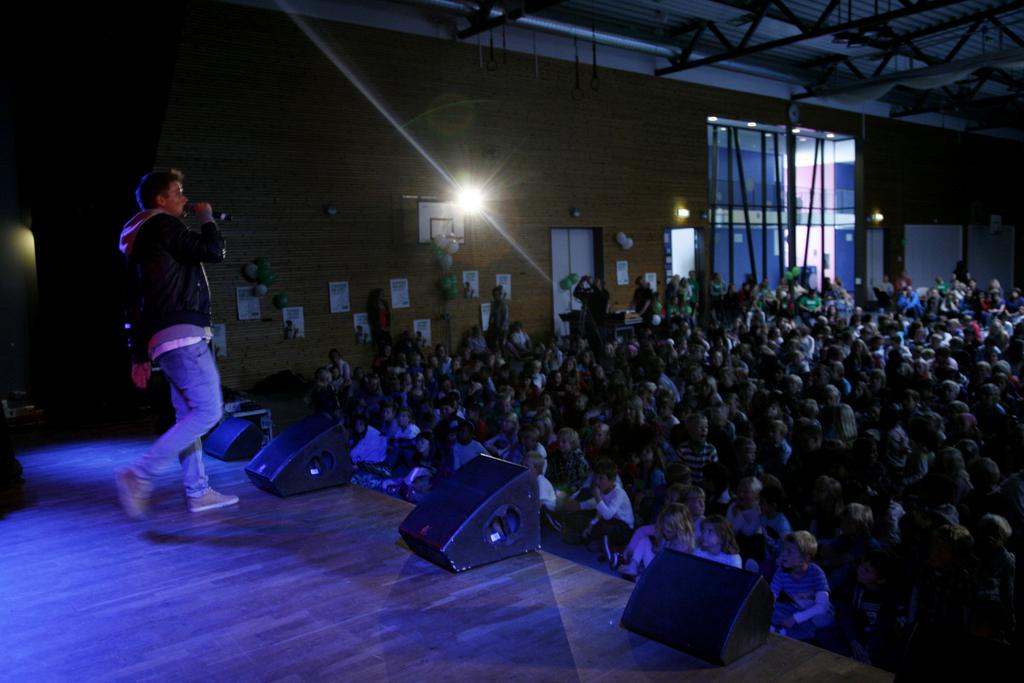What can be seen in the image in terms of people? There are groups of people in the image. What type of structure is present in the image? There is a wall in the image. Are there any openings in the wall? Yes, there is a door in the image. What can be seen in the image that provides illumination? There are lights in the image. What is the person on the left side of the image holding? The person on the left side is holding a microphone. What riddle is being solved by the person on the right side of the image? There is no riddle being solved in the image; the person on the right side is part of a group of people. What calendar is being used by the person on the left side of the image? There is no calendar present in the image; the person on the left side is holding a microphone. 